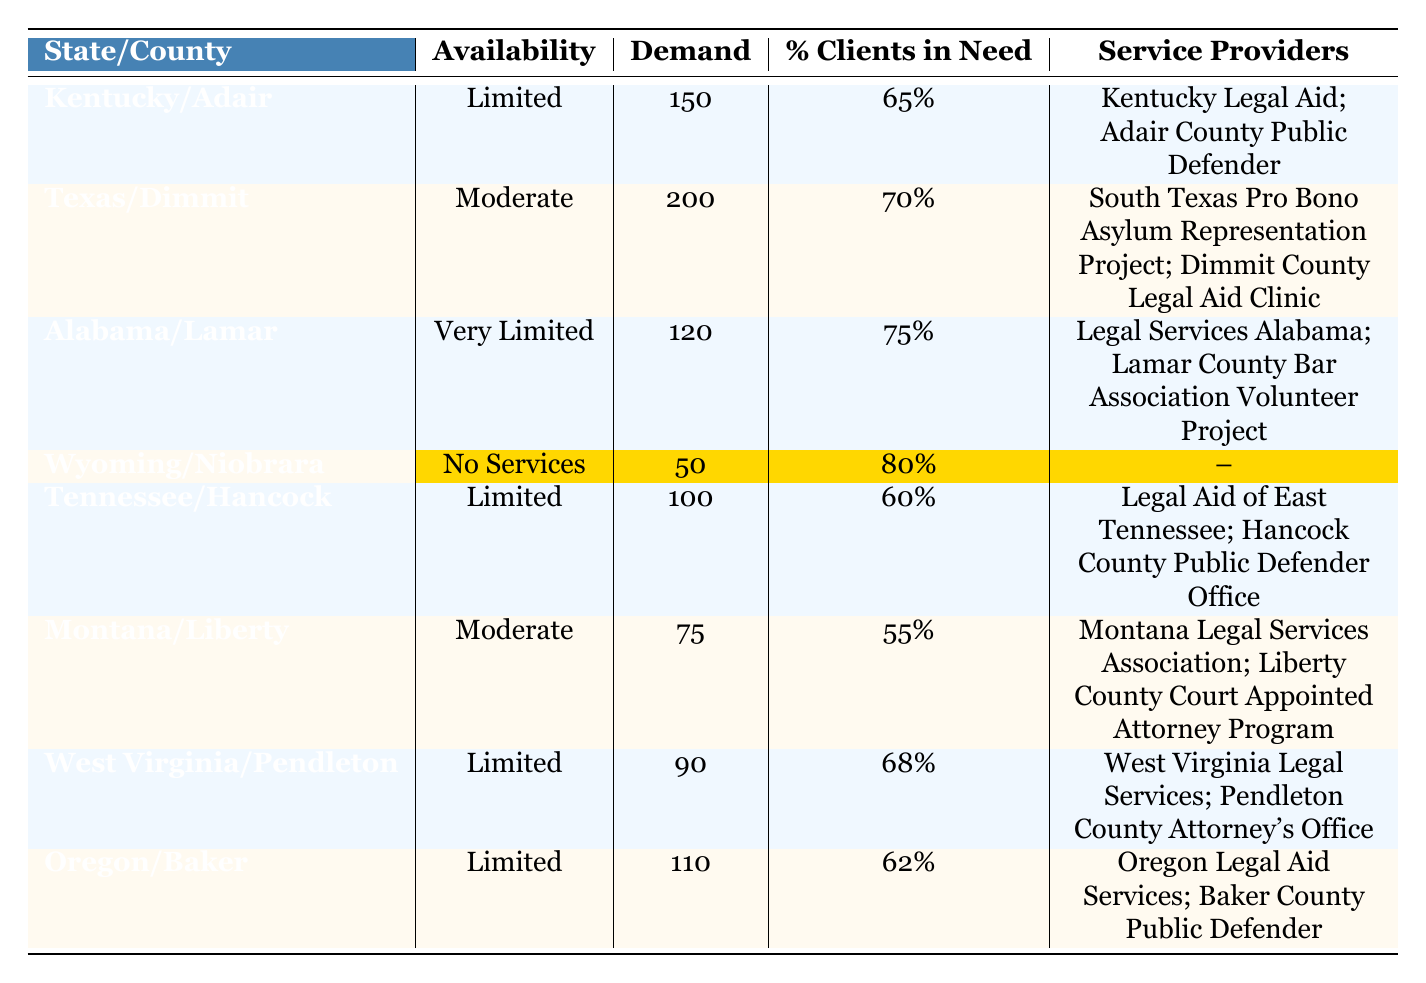What is the availability of legal aid services in Wyoming/Niobrara? The table indicates that Wyoming/Niobrara has “No Services” for legal aid availability.
Answer: No Services How many legal aid service providers are there in Alabama/Lamar? The table lists two service providers for Alabama/Lamar: Legal Services Alabama and Lamar County Bar Association Volunteer Project.
Answer: 2 Which county has the highest demand for legal aid services? By examining the demand values listed, Texas/Dimmit has the highest demand at 200.
Answer: Texas/Dimmit What percentage of clients in need is there in Kentucky/Adair? The table shows that the percentage of clients in need for Kentucky/Adair is 65%.
Answer: 65% Is there any county listed that has no legal aid services available? Yes, the table highlights Wyoming/Niobrara as having “No Services” in the availability column.
Answer: Yes What is the total demand for legal aid services across the states listed in the table? To find the total demand, sum up all the demands: 150 + 200 + 120 + 50 + 100 + 75 + 90 + 110 = 895.
Answer: 895 Which state has the highest percentage of clients in need, and what is that percentage? The table shows that Alabama/Lamar has the highest percentage at 75%.
Answer: Alabama/Lamar, 75% If you consider only counties with limited availability, what is the average percentage of clients in need in those counties? The limited availability counties are Kentucky/Adair (65%), Tennessee/Hancock (60%), West Virginia/Pendleton (68%), and Oregon/Baker (62%). The average is (65 + 60 + 68 + 62) / 4 = 63.75.
Answer: 63.75 Which state has the lowest demand for legal aid services, and what is the demand? By comparing the demand values, Wyoming/Niobrara has the lowest demand at 50.
Answer: Wyoming/Niobrara, 50 Are there any counties where the percentage of clients in need is higher than the demand? Yes, Wyoming/Niobrara has 80% of clients in need, but the demand is only 50.
Answer: Yes 